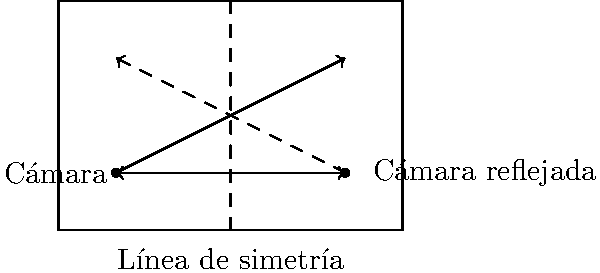En el diagrama, se muestra una cámara de seguridad y su campo de visión en un área rectangular. La línea punteada vertical representa una línea de simetría. Si reflejamos la cámara y su campo de visión a través de esta línea de simetría, ¿cuáles serían las coordenadas de la cámara reflejada? Para resolver este problema, seguiremos estos pasos:

1) Primero, identifiquemos las coordenadas de la cámara original. En el diagrama, la cámara está ubicada en el punto (1,1).

2) La línea de simetría es una línea vertical que pasa por el punto medio del rectángulo. Como el rectángulo tiene un ancho de 6 unidades, la línea de simetría está en x = 3.

3) Para reflejar un punto a través de una línea vertical, la coordenada y permanece igual, mientras que la coordenada x cambia. La nueva coordenada x será tan lejos de la línea de simetría al lado opuesto como lo estaba originalmente.

4) La distancia de la cámara original a la línea de simetría es:
   $3 - 1 = 2$ unidades a la izquierda

5) Por lo tanto, la cámara reflejada estará 2 unidades a la derecha de la línea de simetría.

6) Calculemos la nueva coordenada x:
   $3 + 2 = 5$

7) La coordenada y no cambia, sigue siendo 1.

Por lo tanto, las coordenadas de la cámara reflejada son (5,1).
Answer: (5,1) 